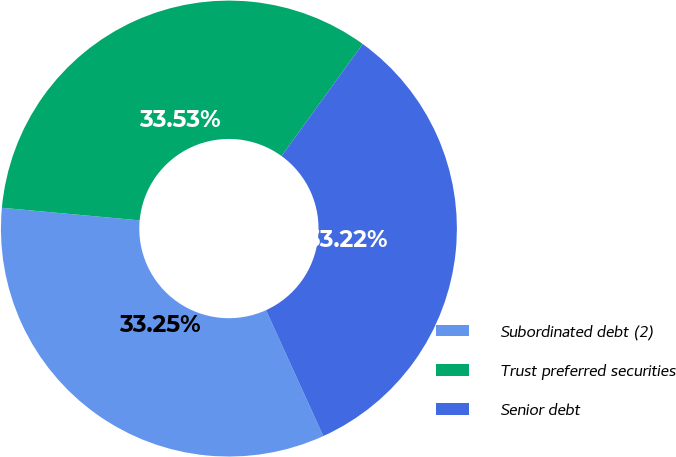<chart> <loc_0><loc_0><loc_500><loc_500><pie_chart><fcel>Subordinated debt (2)<fcel>Trust preferred securities<fcel>Senior debt<nl><fcel>33.25%<fcel>33.53%<fcel>33.22%<nl></chart> 